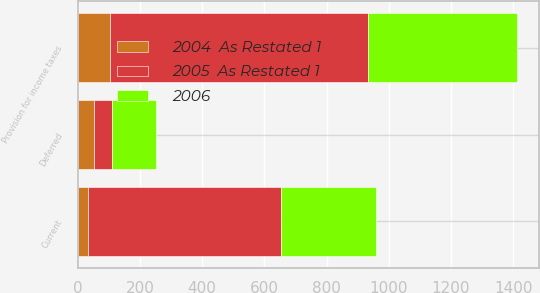Convert chart to OTSL. <chart><loc_0><loc_0><loc_500><loc_500><stacked_bar_chart><ecel><fcel>Current<fcel>Deferred<fcel>Provision for income taxes<nl><fcel>2005  As Restated 1<fcel>619<fcel>56<fcel>829<nl><fcel>2006<fcel>305<fcel>144<fcel>480<nl><fcel>2004  As Restated 1<fcel>34<fcel>53<fcel>104<nl></chart> 